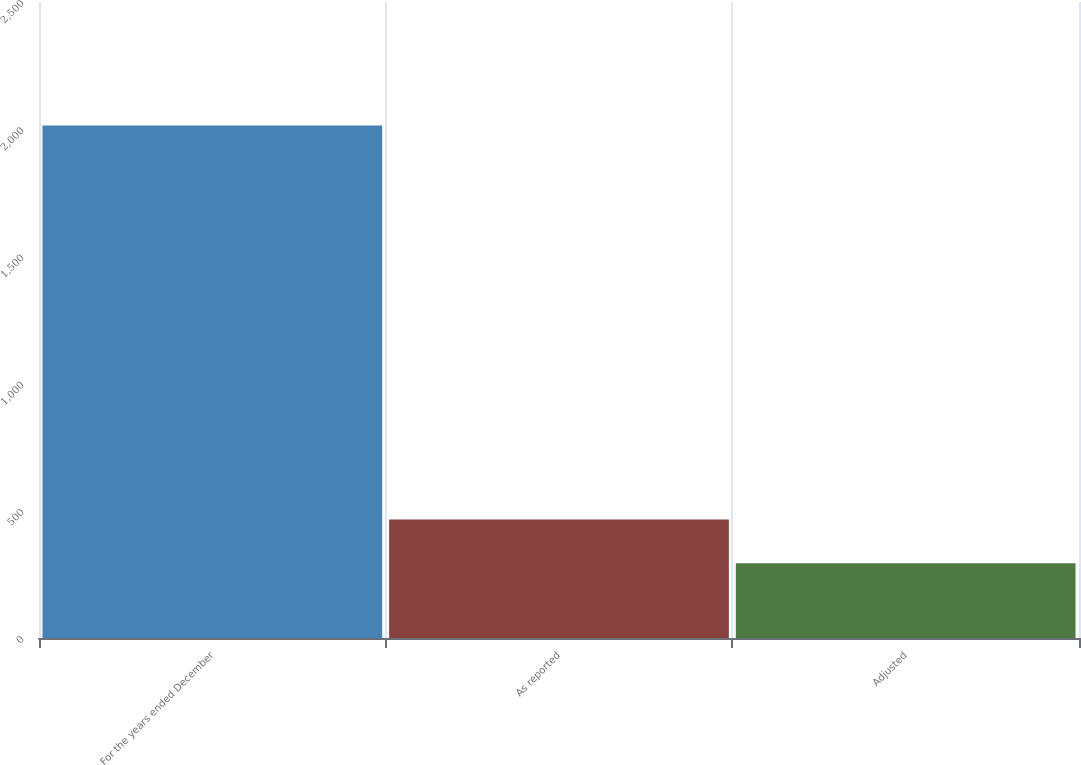<chart> <loc_0><loc_0><loc_500><loc_500><bar_chart><fcel>For the years ended December<fcel>As reported<fcel>Adjusted<nl><fcel>2015<fcel>466.19<fcel>294.1<nl></chart> 